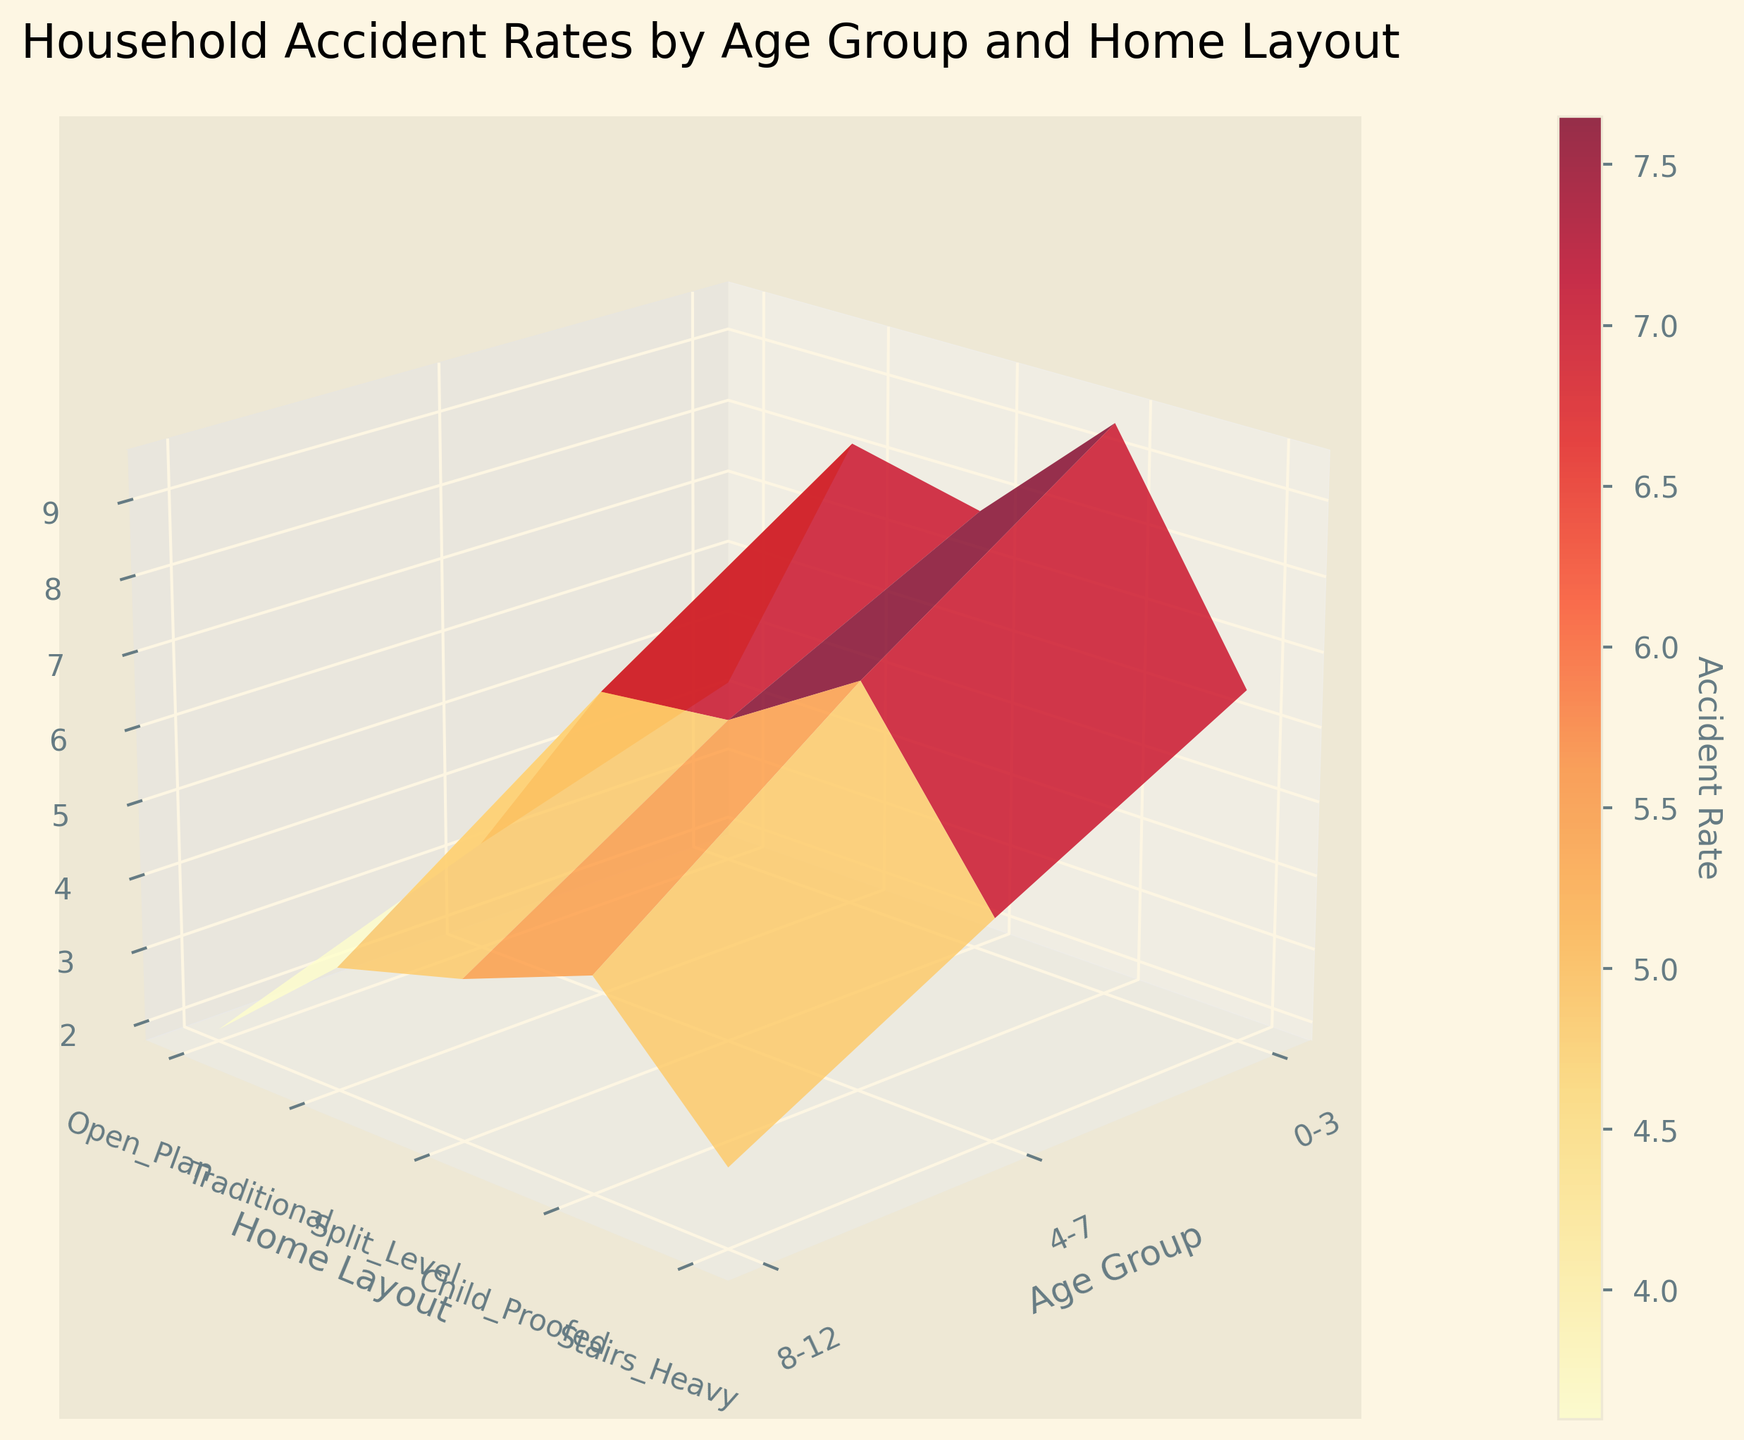What is the title of the 3D plot? The title is usually displayed at the top of the figure, summarizing its contents.
Answer: Household Accident Rates by Age Group and Home Layout Which home layout has the highest accident rate for children aged 0-3? Look at the highest point on the z-axis corresponding to home layouts in the 0-3 age group.
Answer: Stairs_Heavy What is the difference in accident rates between the 'Open Plan' and 'Child-Proofed' layouts for children aged 8-12? Identify the z-values for the 8-12 age group under 'Open Plan' and 'Child-Proofed' layouts and calculate the difference.
Answer: 3.4 - 1.9 = 1.5 Which age group has the lowest accident rate in 'Traditional' home layouts? Compare the z-values for 'Traditional' home layout across different age groups to find the lowest one.
Answer: 8-12 What color scheme is used in the 3D plot? The color scheme indicates which color represents higher or lower values on the z-axis and is generally described in the plot's configuration or legend.
Answer: YlOrRd (yellow to red gradient) How do accident rates change on average as children grow older in 'Stairs Heavy' home layouts? Compute the average rate of change by assessing the rates at different age groups: see the trend from 0-3, 4-7, and 8-12.
Answer: Decrease from 9.5 to 7.2 to 4.6 Which home layout shows the most significant difference in accident rates between the 0-3 and 4-7 age groups? Calculate the differences for each home layout and compare the results to identify the most significant one.
Answer: Stairs_Heavy (9.5 - 7.2 = 2.3) How many age groups are represented in the plot? Count the distinct labels along the x-axis.
Answer: Three (0-3, 4-7, 8-12) In which home layout and age group combination is the accident rate closest to 5? Identify and compare values across all age groups and layouts, then find the one closest to 5.
Answer: Open_Plan (4-7, 5.9) 